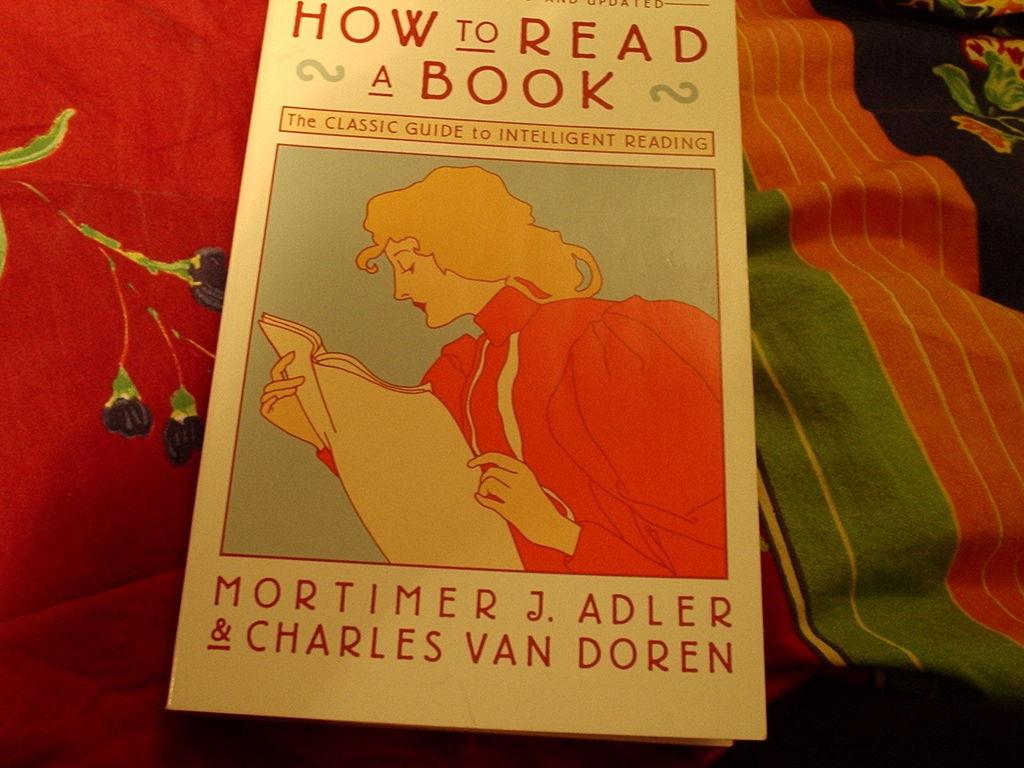What is this the classic guide to?
Provide a succinct answer. Intelligent reading. What is the title of this book?
Offer a very short reply. How to read a book. 